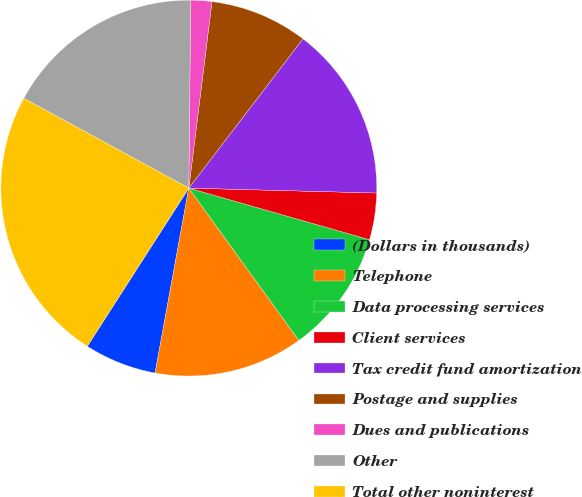Convert chart to OTSL. <chart><loc_0><loc_0><loc_500><loc_500><pie_chart><fcel>(Dollars in thousands)<fcel>Telephone<fcel>Data processing services<fcel>Client services<fcel>Tax credit fund amortization<fcel>Postage and supplies<fcel>Dues and publications<fcel>Other<fcel>Total other noninterest<nl><fcel>6.21%<fcel>12.83%<fcel>10.62%<fcel>4.01%<fcel>15.03%<fcel>8.42%<fcel>1.81%<fcel>17.23%<fcel>23.85%<nl></chart> 